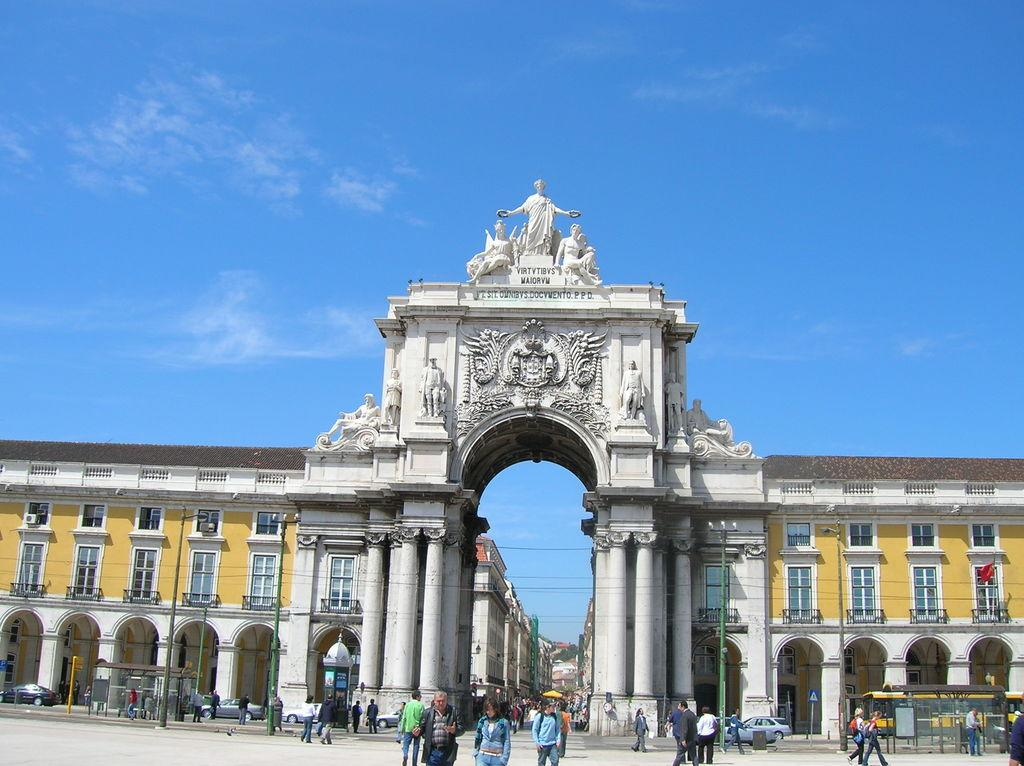What is the main subject of the image? The main subject of the image is the buildings at the center. What else can be seen in front of the buildings? There are vehicles in front of the buildings. Are there any people visible in the image? Yes, there are people on the road. What can be seen in the background of the image? The sky is visible in the background of the image. What type of lettuce is being grown in the image? There is no lettuce present in the image; it features buildings, vehicles, people, and the sky. Can you see any sea creatures in the image? There is no sea or sea creatures present in the image. 